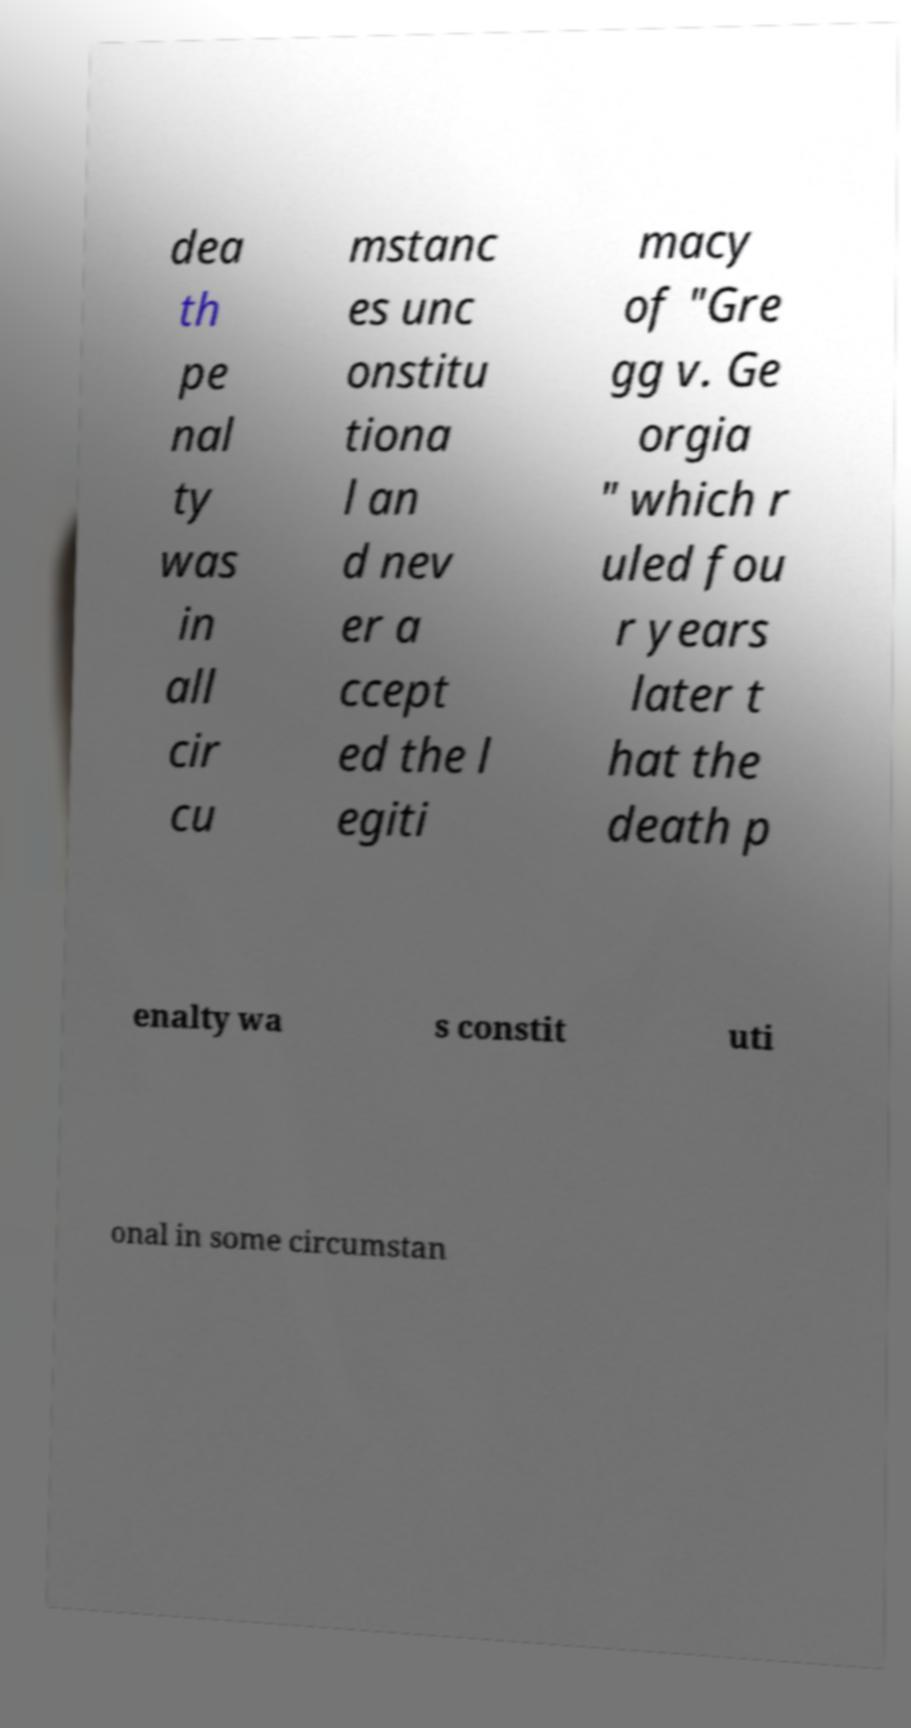There's text embedded in this image that I need extracted. Can you transcribe it verbatim? dea th pe nal ty was in all cir cu mstanc es unc onstitu tiona l an d nev er a ccept ed the l egiti macy of "Gre gg v. Ge orgia " which r uled fou r years later t hat the death p enalty wa s constit uti onal in some circumstan 